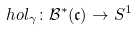Convert formula to latex. <formula><loc_0><loc_0><loc_500><loc_500>\ h o l _ { \gamma } \colon \mathcal { B } ^ { * } ( \mathfrak { c } ) \to S ^ { 1 }</formula> 